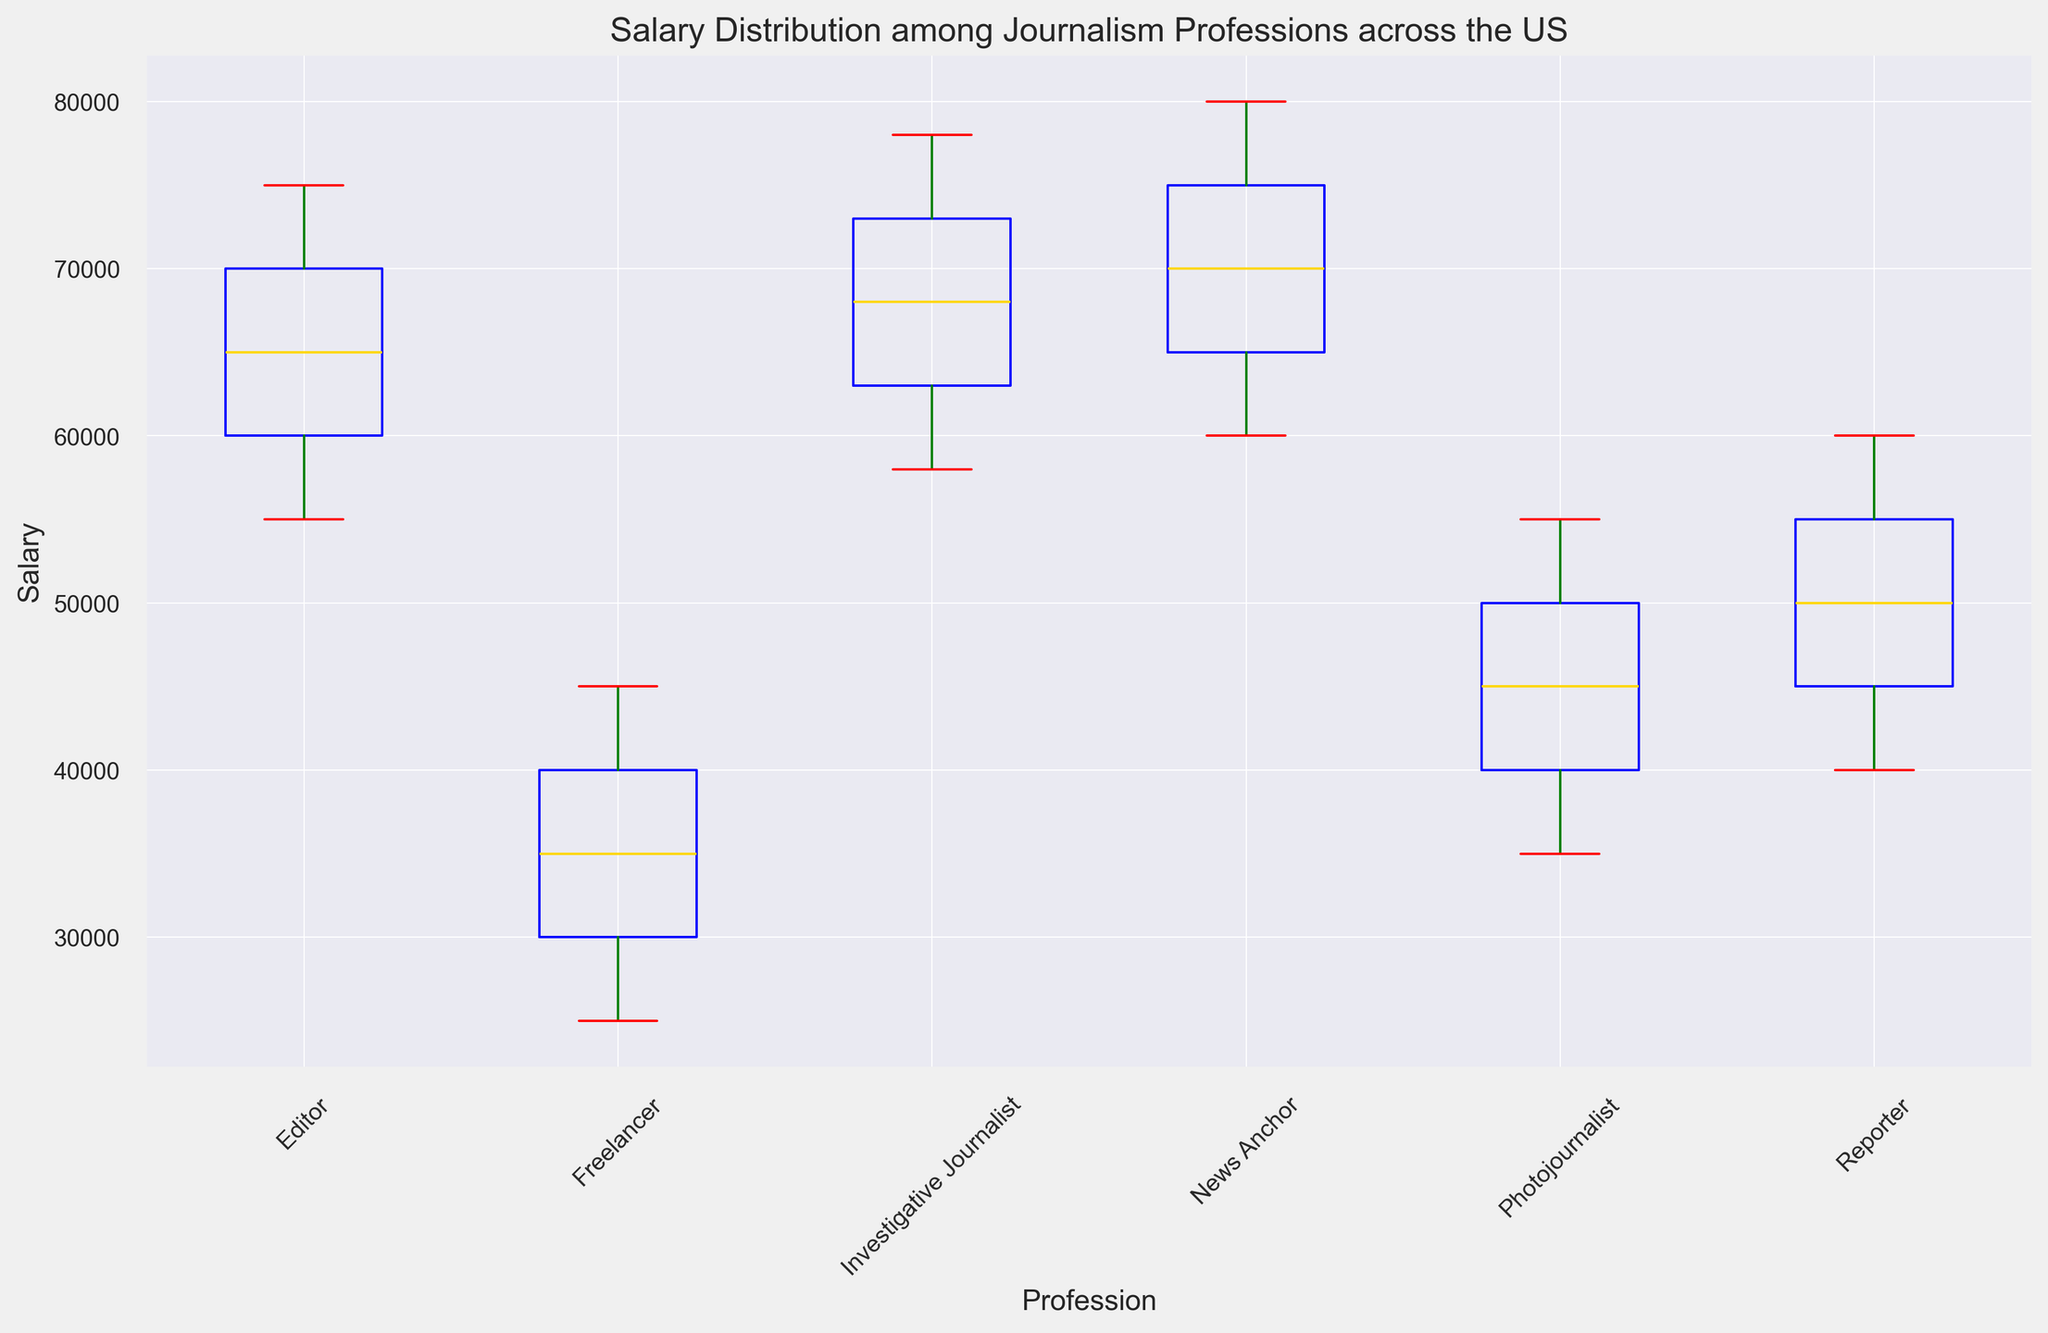What is the profession with the highest median salary? The profession with the highest median salary can be identified by looking at the median lines (usually the horizontal lines inside the boxes) and finding the highest one.
Answer: News Anchor Which profession has the lowest minimum salary? The profession with the lowest minimum salary can be identified by locating the bottom whisker of each box plot and finding the lowest one.
Answer: Freelancer How does the interquartile range (IQR) of Editors compare to that of Reporters? The IQR is the range between the first and third quartiles (the top and bottom of the box itself). To compare, look at the height of the boxes for Editors and Reporters. The height difference will show if one is greater or if they are similar.
Answer: Editor has a larger IQR than Reporter Which profession has the widest range of salaries? The range of salaries can be determined by the distance between the top and bottom whiskers. Comparing these distances among professions reveals the widest range.
Answer: Freelancer What is the median salary for Photojournalists? The median salary is represented by the line within the box for Photojournalists. Locate this line to identify the median salary.
Answer: $45,000 By how much is the median salary of News Anchors higher than that of Freelancers? Find the median salary for each profession and subtract the median of Freelancers from the median of News Anchors.
Answer: $35,000 Which two professions have the most similar median salaries? Compare the median lines within the boxes of each profession to see which two are closest in value.
Answer: Editor and Investigative Journalist Which profession has the least dispersed salaries? The least dispersed salaries can be identified by looking for the profession with the smallest box (smallest IQR) and shortest whiskers.
Answer: Reporter 